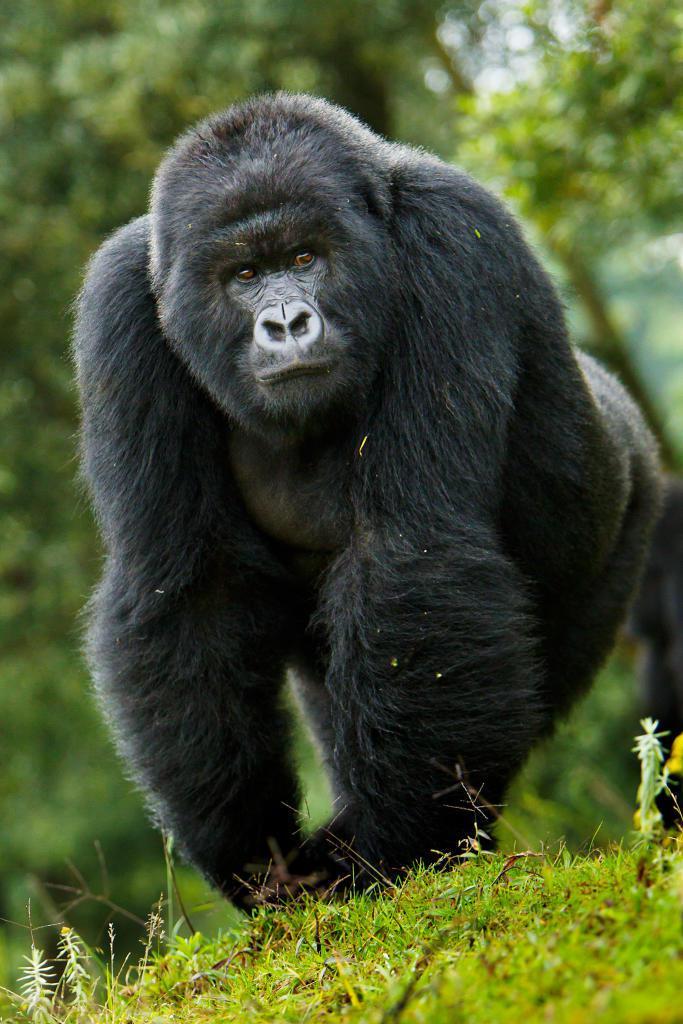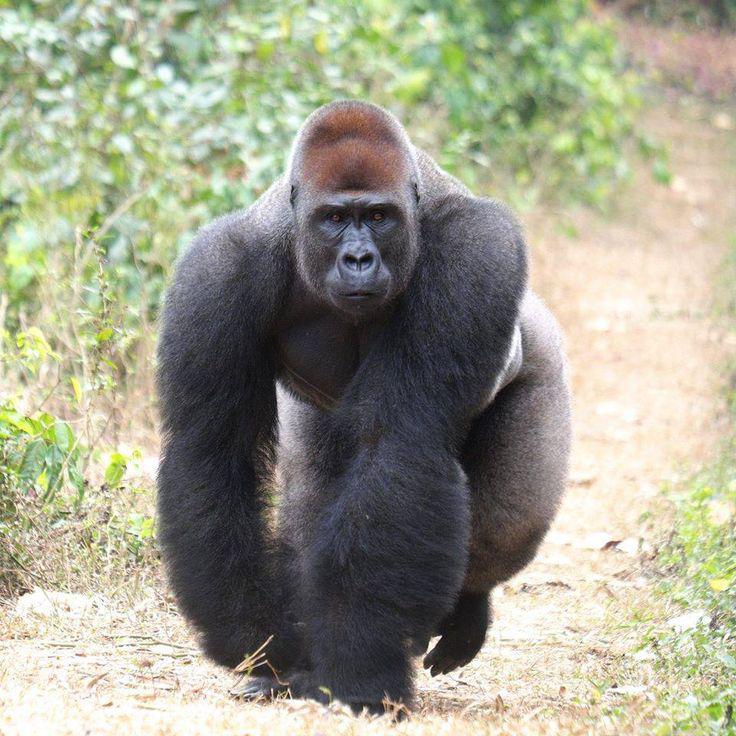The first image is the image on the left, the second image is the image on the right. Given the left and right images, does the statement "One of the animals is sitting on the ground." hold true? Answer yes or no. No. 